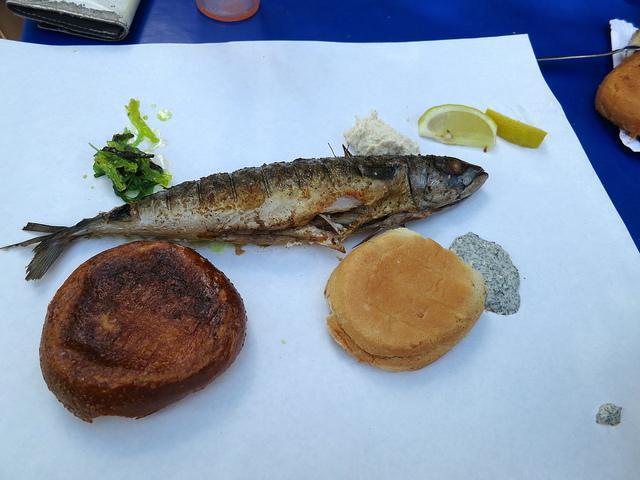How many lemon slices are in this photo?
Give a very brief answer. 2. How many dining tables are there?
Give a very brief answer. 1. How many bottle caps are in the photo?
Give a very brief answer. 0. 